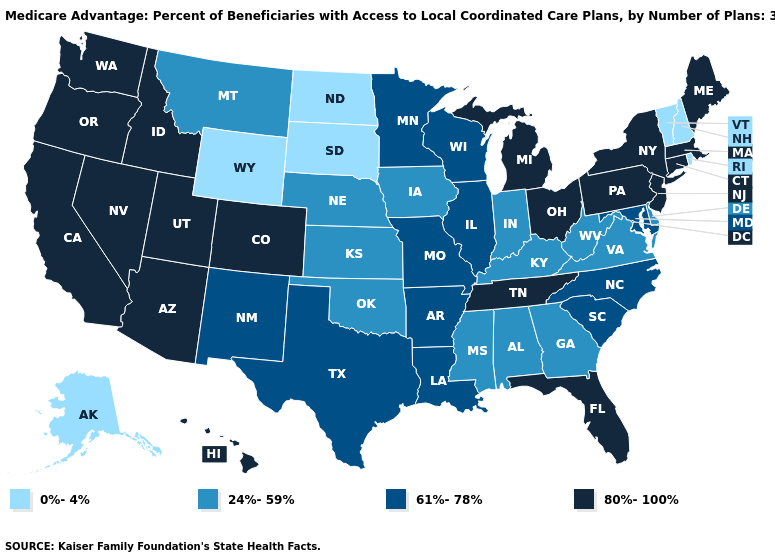Name the states that have a value in the range 0%-4%?
Answer briefly. Alaska, North Dakota, New Hampshire, Rhode Island, South Dakota, Vermont, Wyoming. Name the states that have a value in the range 80%-100%?
Short answer required. Arizona, California, Colorado, Connecticut, Florida, Hawaii, Idaho, Massachusetts, Maine, Michigan, New Jersey, Nevada, New York, Ohio, Oregon, Pennsylvania, Tennessee, Utah, Washington. Does Michigan have a higher value than Minnesota?
Answer briefly. Yes. Name the states that have a value in the range 61%-78%?
Concise answer only. Arkansas, Illinois, Louisiana, Maryland, Minnesota, Missouri, North Carolina, New Mexico, South Carolina, Texas, Wisconsin. Name the states that have a value in the range 80%-100%?
Answer briefly. Arizona, California, Colorado, Connecticut, Florida, Hawaii, Idaho, Massachusetts, Maine, Michigan, New Jersey, Nevada, New York, Ohio, Oregon, Pennsylvania, Tennessee, Utah, Washington. What is the value of Vermont?
Give a very brief answer. 0%-4%. What is the lowest value in states that border Utah?
Write a very short answer. 0%-4%. Does Georgia have the lowest value in the South?
Answer briefly. Yes. Name the states that have a value in the range 24%-59%?
Be succinct. Alabama, Delaware, Georgia, Iowa, Indiana, Kansas, Kentucky, Mississippi, Montana, Nebraska, Oklahoma, Virginia, West Virginia. Name the states that have a value in the range 0%-4%?
Keep it brief. Alaska, North Dakota, New Hampshire, Rhode Island, South Dakota, Vermont, Wyoming. What is the value of Louisiana?
Concise answer only. 61%-78%. What is the lowest value in the USA?
Write a very short answer. 0%-4%. What is the value of Virginia?
Concise answer only. 24%-59%. Which states have the lowest value in the USA?
Short answer required. Alaska, North Dakota, New Hampshire, Rhode Island, South Dakota, Vermont, Wyoming. 